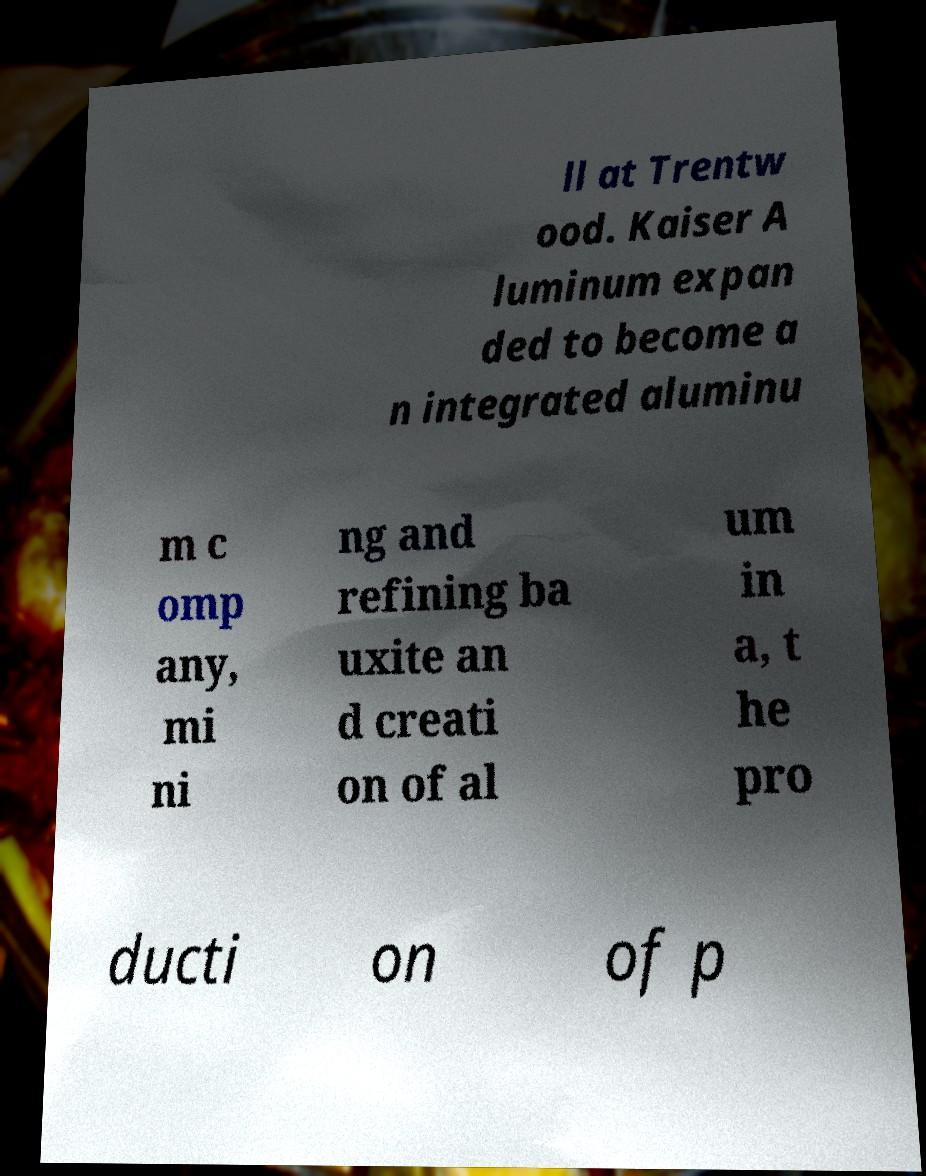Can you accurately transcribe the text from the provided image for me? ll at Trentw ood. Kaiser A luminum expan ded to become a n integrated aluminu m c omp any, mi ni ng and refining ba uxite an d creati on of al um in a, t he pro ducti on of p 